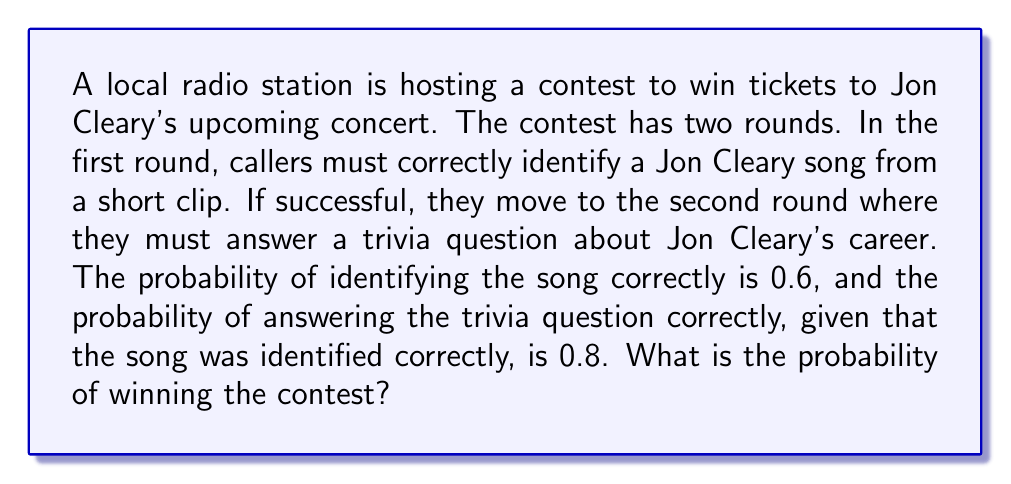Teach me how to tackle this problem. Let's approach this step-by-step using conditional probability:

1) Let A be the event of correctly identifying the song in the first round.
2) Let B be the event of correctly answering the trivia question in the second round.

We're given:
$P(A) = 0.6$
$P(B|A) = 0.8$

To win the contest, a caller needs to succeed in both rounds. This is the intersection of events A and B, denoted as $A \cap B$.

The probability of this intersection can be calculated using the conditional probability formula:

$$P(A \cap B) = P(A) \cdot P(B|A)$$

Substituting the given probabilities:

$$P(A \cap B) = 0.6 \cdot 0.8 = 0.48$$

Therefore, the probability of winning the contest is 0.48 or 48%.
Answer: $0.48$ 